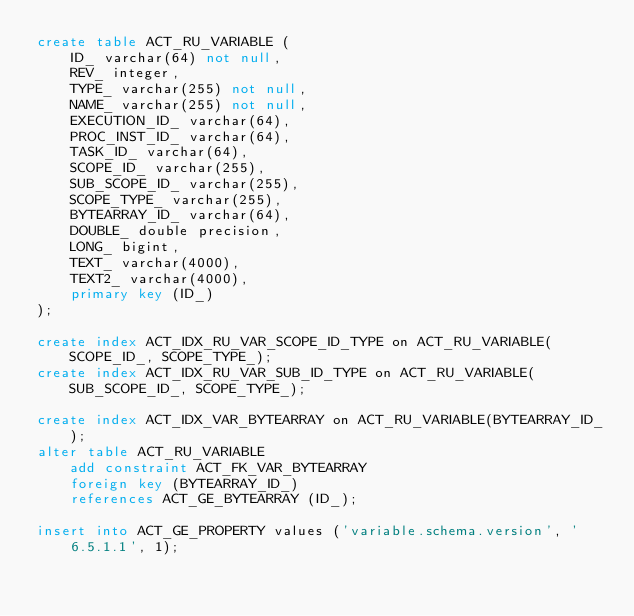Convert code to text. <code><loc_0><loc_0><loc_500><loc_500><_SQL_>create table ACT_RU_VARIABLE (
    ID_ varchar(64) not null,
    REV_ integer,
    TYPE_ varchar(255) not null,
    NAME_ varchar(255) not null,
    EXECUTION_ID_ varchar(64),
    PROC_INST_ID_ varchar(64),
    TASK_ID_ varchar(64),
    SCOPE_ID_ varchar(255),
    SUB_SCOPE_ID_ varchar(255),
    SCOPE_TYPE_ varchar(255),
    BYTEARRAY_ID_ varchar(64),
    DOUBLE_ double precision,
    LONG_ bigint,
    TEXT_ varchar(4000),
    TEXT2_ varchar(4000),
    primary key (ID_)
);

create index ACT_IDX_RU_VAR_SCOPE_ID_TYPE on ACT_RU_VARIABLE(SCOPE_ID_, SCOPE_TYPE_);
create index ACT_IDX_RU_VAR_SUB_ID_TYPE on ACT_RU_VARIABLE(SUB_SCOPE_ID_, SCOPE_TYPE_);

create index ACT_IDX_VAR_BYTEARRAY on ACT_RU_VARIABLE(BYTEARRAY_ID_);
alter table ACT_RU_VARIABLE 
    add constraint ACT_FK_VAR_BYTEARRAY 
    foreign key (BYTEARRAY_ID_) 
    references ACT_GE_BYTEARRAY (ID_);

insert into ACT_GE_PROPERTY values ('variable.schema.version', '6.5.1.1', 1);
</code> 